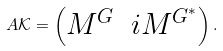<formula> <loc_0><loc_0><loc_500><loc_500>A \mathcal { K } = \begin{pmatrix} M ^ { G } & i M ^ { G ^ { * } } \end{pmatrix} .</formula> 